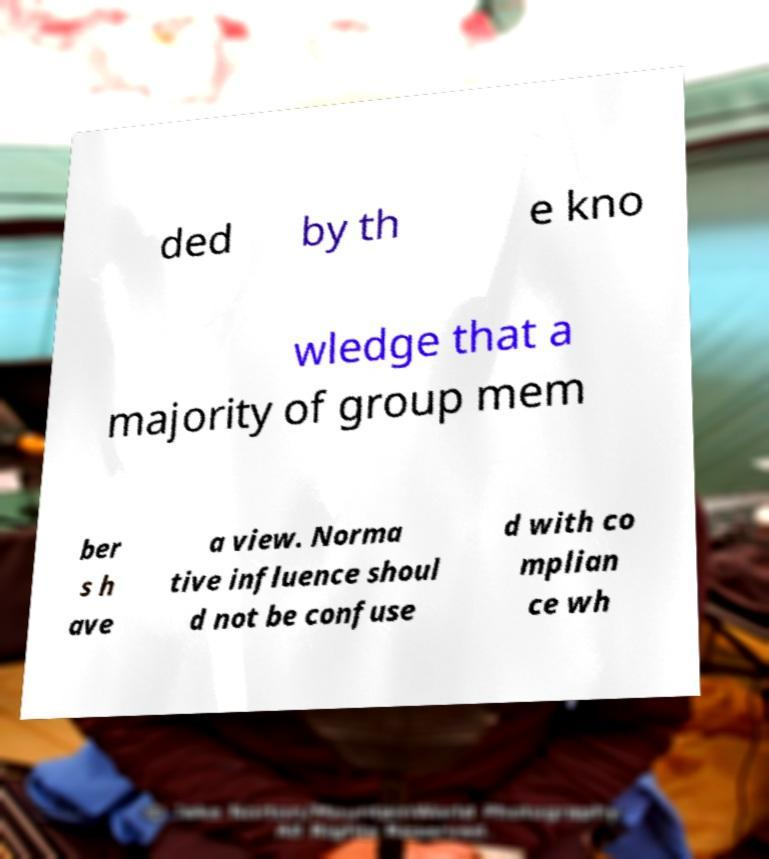For documentation purposes, I need the text within this image transcribed. Could you provide that? ded by th e kno wledge that a majority of group mem ber s h ave a view. Norma tive influence shoul d not be confuse d with co mplian ce wh 